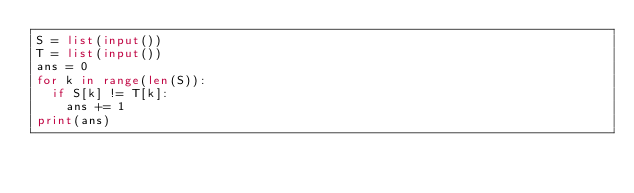<code> <loc_0><loc_0><loc_500><loc_500><_Python_>S = list(input())
T = list(input())
ans = 0
for k in range(len(S)):
  if S[k] != T[k]:
    ans += 1
print(ans)</code> 